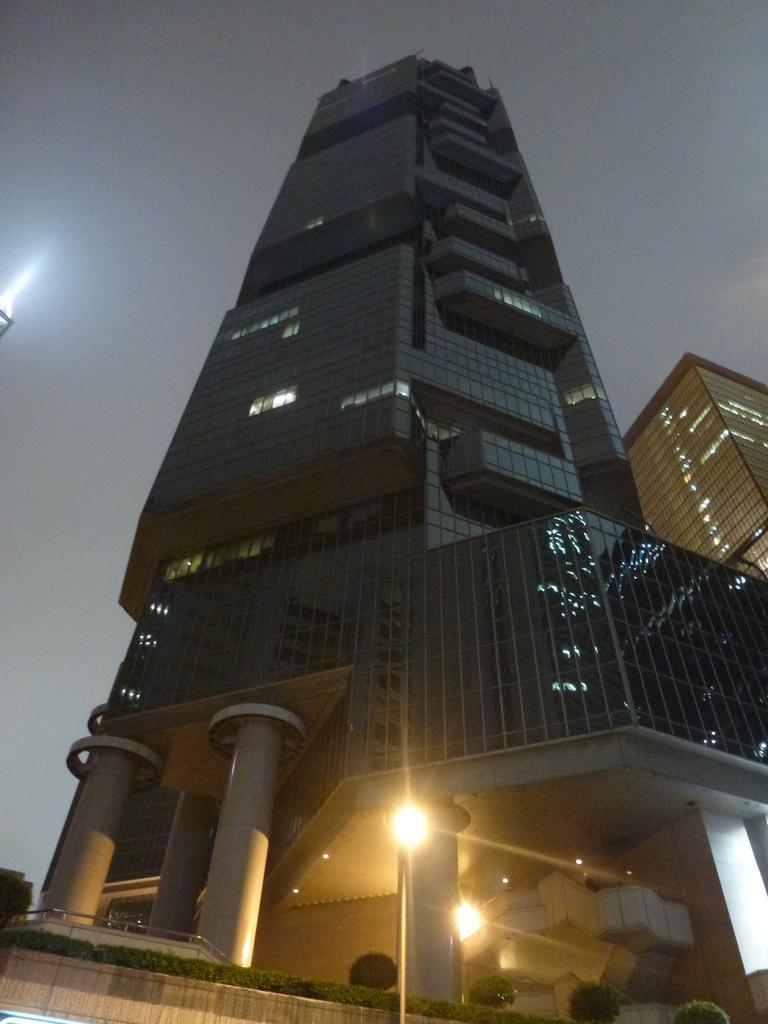Can you describe this image briefly? In this picture, we can see a few glass buildings, pillars, lights, trees, plants, and the sky. 